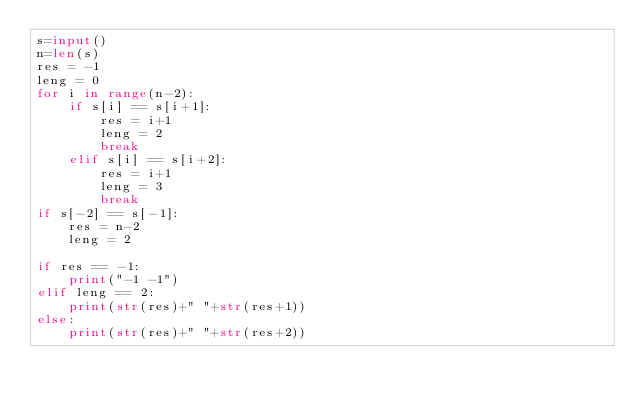<code> <loc_0><loc_0><loc_500><loc_500><_Python_>s=input()
n=len(s)
res = -1
leng = 0
for i in range(n-2):
    if s[i] == s[i+1]:
        res = i+1
        leng = 2
        break
    elif s[i] == s[i+2]:
        res = i+1
        leng = 3
        break
if s[-2] == s[-1]:
    res = n-2
    leng = 2

if res == -1:
    print("-1 -1")
elif leng == 2:
    print(str(res)+" "+str(res+1))
else:
    print(str(res)+" "+str(res+2))</code> 